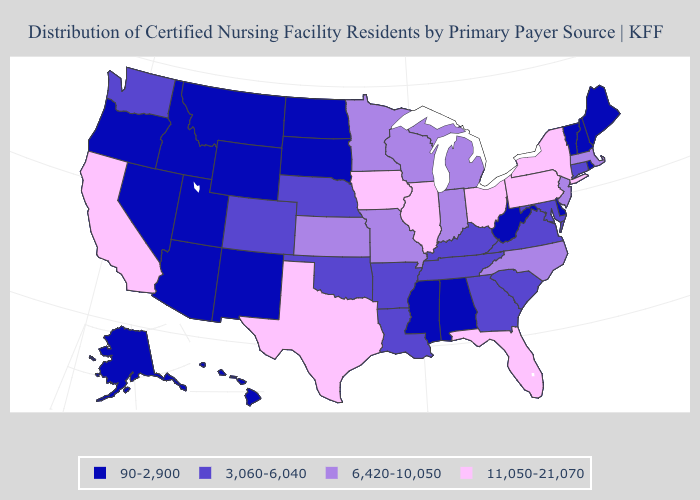Name the states that have a value in the range 90-2,900?
Answer briefly. Alabama, Alaska, Arizona, Delaware, Hawaii, Idaho, Maine, Mississippi, Montana, Nevada, New Hampshire, New Mexico, North Dakota, Oregon, Rhode Island, South Dakota, Utah, Vermont, West Virginia, Wyoming. Name the states that have a value in the range 6,420-10,050?
Short answer required. Indiana, Kansas, Massachusetts, Michigan, Minnesota, Missouri, New Jersey, North Carolina, Wisconsin. Name the states that have a value in the range 3,060-6,040?
Short answer required. Arkansas, Colorado, Connecticut, Georgia, Kentucky, Louisiana, Maryland, Nebraska, Oklahoma, South Carolina, Tennessee, Virginia, Washington. Does Nebraska have a lower value than Missouri?
Be succinct. Yes. Name the states that have a value in the range 6,420-10,050?
Give a very brief answer. Indiana, Kansas, Massachusetts, Michigan, Minnesota, Missouri, New Jersey, North Carolina, Wisconsin. Name the states that have a value in the range 11,050-21,070?
Give a very brief answer. California, Florida, Illinois, Iowa, New York, Ohio, Pennsylvania, Texas. Does Alaska have the lowest value in the West?
Write a very short answer. Yes. Name the states that have a value in the range 11,050-21,070?
Write a very short answer. California, Florida, Illinois, Iowa, New York, Ohio, Pennsylvania, Texas. Does Nebraska have the highest value in the MidWest?
Quick response, please. No. What is the highest value in the USA?
Concise answer only. 11,050-21,070. Which states hav the highest value in the Northeast?
Concise answer only. New York, Pennsylvania. What is the highest value in the MidWest ?
Keep it brief. 11,050-21,070. Name the states that have a value in the range 6,420-10,050?
Answer briefly. Indiana, Kansas, Massachusetts, Michigan, Minnesota, Missouri, New Jersey, North Carolina, Wisconsin. What is the highest value in states that border Arizona?
Give a very brief answer. 11,050-21,070. Name the states that have a value in the range 3,060-6,040?
Short answer required. Arkansas, Colorado, Connecticut, Georgia, Kentucky, Louisiana, Maryland, Nebraska, Oklahoma, South Carolina, Tennessee, Virginia, Washington. 